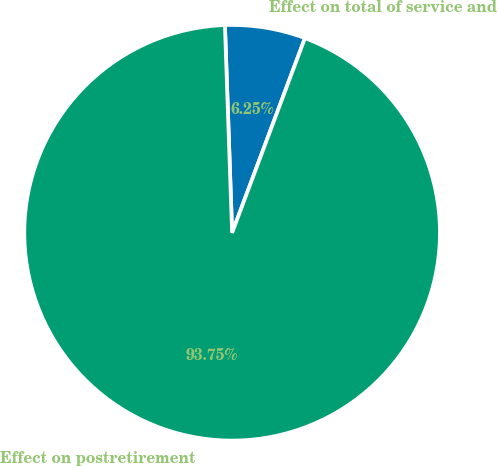<chart> <loc_0><loc_0><loc_500><loc_500><pie_chart><fcel>Effect on total of service and<fcel>Effect on postretirement<nl><fcel>6.25%<fcel>93.75%<nl></chart> 